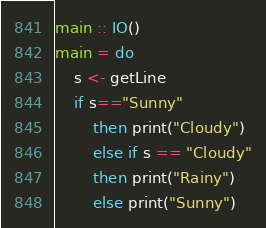Convert code to text. <code><loc_0><loc_0><loc_500><loc_500><_Haskell_>main :: IO()
main = do
    s <- getLine
    if s=="Sunny"
        then print("Cloudy")
        else if s == "Cloudy"
        then print("Rainy")
        else print("Sunny")
</code> 